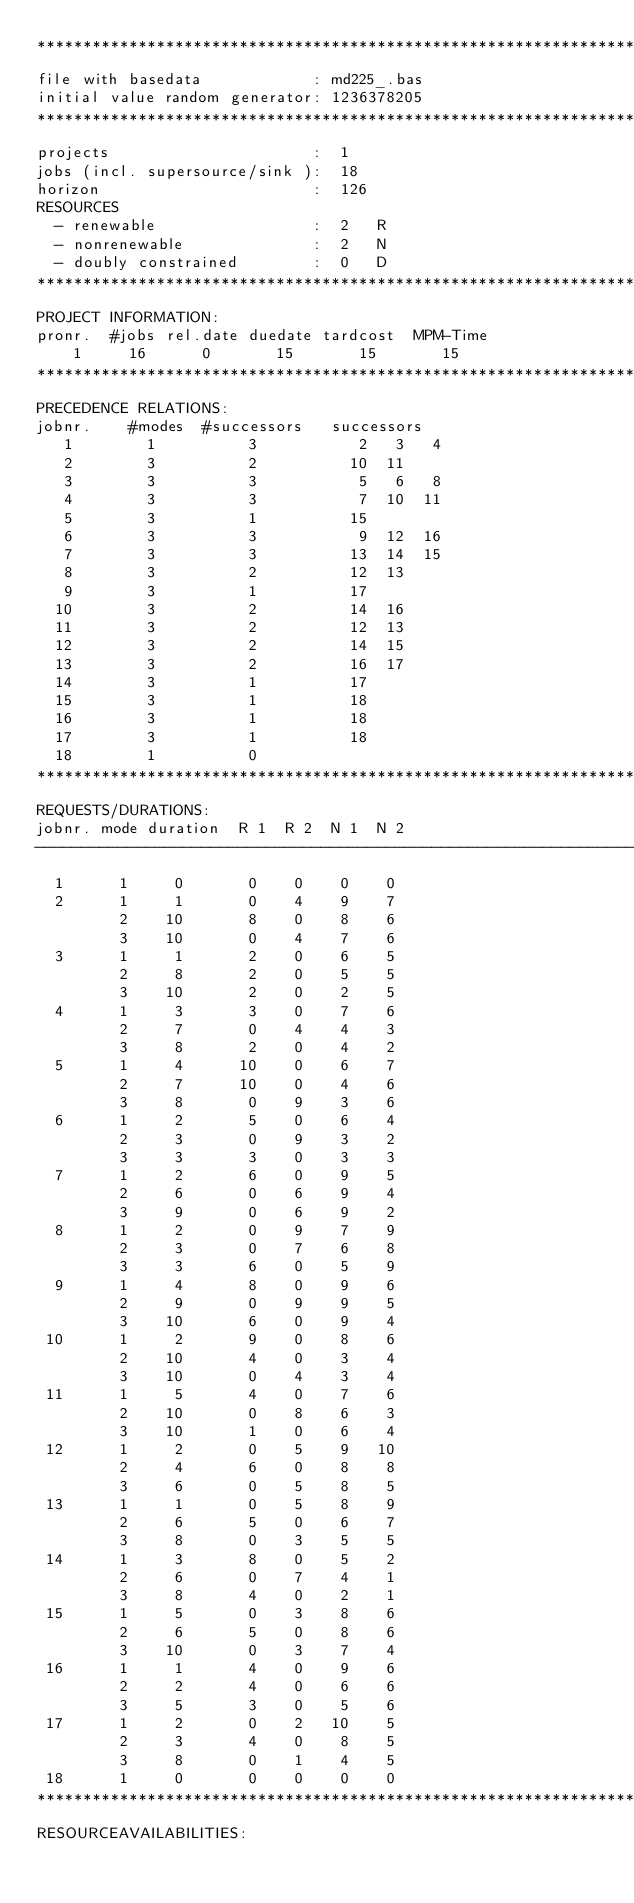<code> <loc_0><loc_0><loc_500><loc_500><_ObjectiveC_>************************************************************************
file with basedata            : md225_.bas
initial value random generator: 1236378205
************************************************************************
projects                      :  1
jobs (incl. supersource/sink ):  18
horizon                       :  126
RESOURCES
  - renewable                 :  2   R
  - nonrenewable              :  2   N
  - doubly constrained        :  0   D
************************************************************************
PROJECT INFORMATION:
pronr.  #jobs rel.date duedate tardcost  MPM-Time
    1     16      0       15       15       15
************************************************************************
PRECEDENCE RELATIONS:
jobnr.    #modes  #successors   successors
   1        1          3           2   3   4
   2        3          2          10  11
   3        3          3           5   6   8
   4        3          3           7  10  11
   5        3          1          15
   6        3          3           9  12  16
   7        3          3          13  14  15
   8        3          2          12  13
   9        3          1          17
  10        3          2          14  16
  11        3          2          12  13
  12        3          2          14  15
  13        3          2          16  17
  14        3          1          17
  15        3          1          18
  16        3          1          18
  17        3          1          18
  18        1          0        
************************************************************************
REQUESTS/DURATIONS:
jobnr. mode duration  R 1  R 2  N 1  N 2
------------------------------------------------------------------------
  1      1     0       0    0    0    0
  2      1     1       0    4    9    7
         2    10       8    0    8    6
         3    10       0    4    7    6
  3      1     1       2    0    6    5
         2     8       2    0    5    5
         3    10       2    0    2    5
  4      1     3       3    0    7    6
         2     7       0    4    4    3
         3     8       2    0    4    2
  5      1     4      10    0    6    7
         2     7      10    0    4    6
         3     8       0    9    3    6
  6      1     2       5    0    6    4
         2     3       0    9    3    2
         3     3       3    0    3    3
  7      1     2       6    0    9    5
         2     6       0    6    9    4
         3     9       0    6    9    2
  8      1     2       0    9    7    9
         2     3       0    7    6    8
         3     3       6    0    5    9
  9      1     4       8    0    9    6
         2     9       0    9    9    5
         3    10       6    0    9    4
 10      1     2       9    0    8    6
         2    10       4    0    3    4
         3    10       0    4    3    4
 11      1     5       4    0    7    6
         2    10       0    8    6    3
         3    10       1    0    6    4
 12      1     2       0    5    9   10
         2     4       6    0    8    8
         3     6       0    5    8    5
 13      1     1       0    5    8    9
         2     6       5    0    6    7
         3     8       0    3    5    5
 14      1     3       8    0    5    2
         2     6       0    7    4    1
         3     8       4    0    2    1
 15      1     5       0    3    8    6
         2     6       5    0    8    6
         3    10       0    3    7    4
 16      1     1       4    0    9    6
         2     2       4    0    6    6
         3     5       3    0    5    6
 17      1     2       0    2   10    5
         2     3       4    0    8    5
         3     8       0    1    4    5
 18      1     0       0    0    0    0
************************************************************************
RESOURCEAVAILABILITIES:</code> 